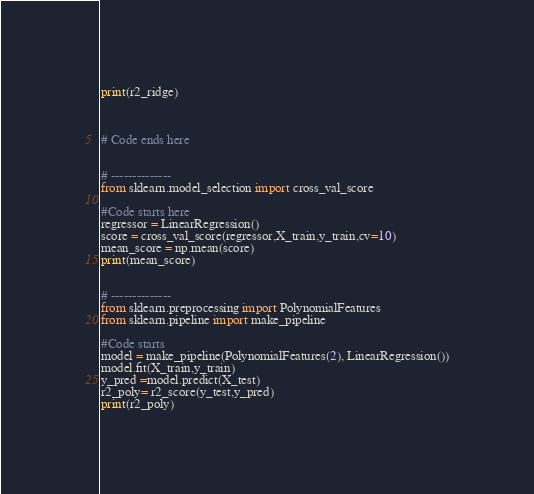<code> <loc_0><loc_0><loc_500><loc_500><_Python_>print(r2_ridge)



# Code ends here


# --------------
from sklearn.model_selection import cross_val_score

#Code starts here
regressor = LinearRegression()
score = cross_val_score(regressor,X_train,y_train,cv=10)
mean_score = np.mean(score)
print(mean_score)


# --------------
from sklearn.preprocessing import PolynomialFeatures
from sklearn.pipeline import make_pipeline

#Code starts 
model = make_pipeline(PolynomialFeatures(2), LinearRegression())
model.fit(X_train,y_train)
y_pred =model.predict(X_test)
r2_poly= r2_score(y_test,y_pred)
print(r2_poly)


</code> 